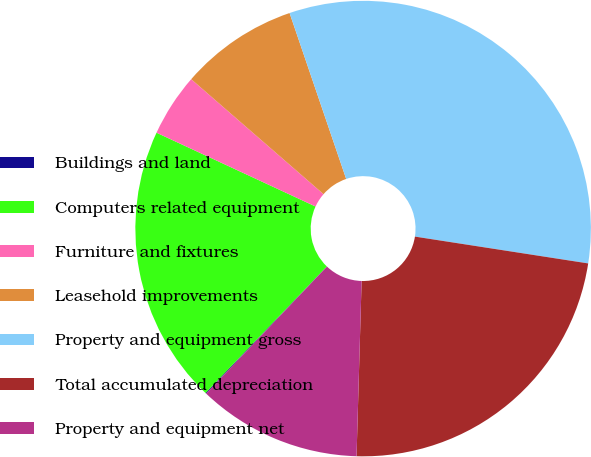Convert chart. <chart><loc_0><loc_0><loc_500><loc_500><pie_chart><fcel>Buildings and land<fcel>Computers related equipment<fcel>Furniture and fixtures<fcel>Leasehold improvements<fcel>Property and equipment gross<fcel>Total accumulated depreciation<fcel>Property and equipment net<nl><fcel>0.06%<fcel>19.75%<fcel>4.47%<fcel>8.38%<fcel>32.67%<fcel>23.01%<fcel>11.64%<nl></chart> 